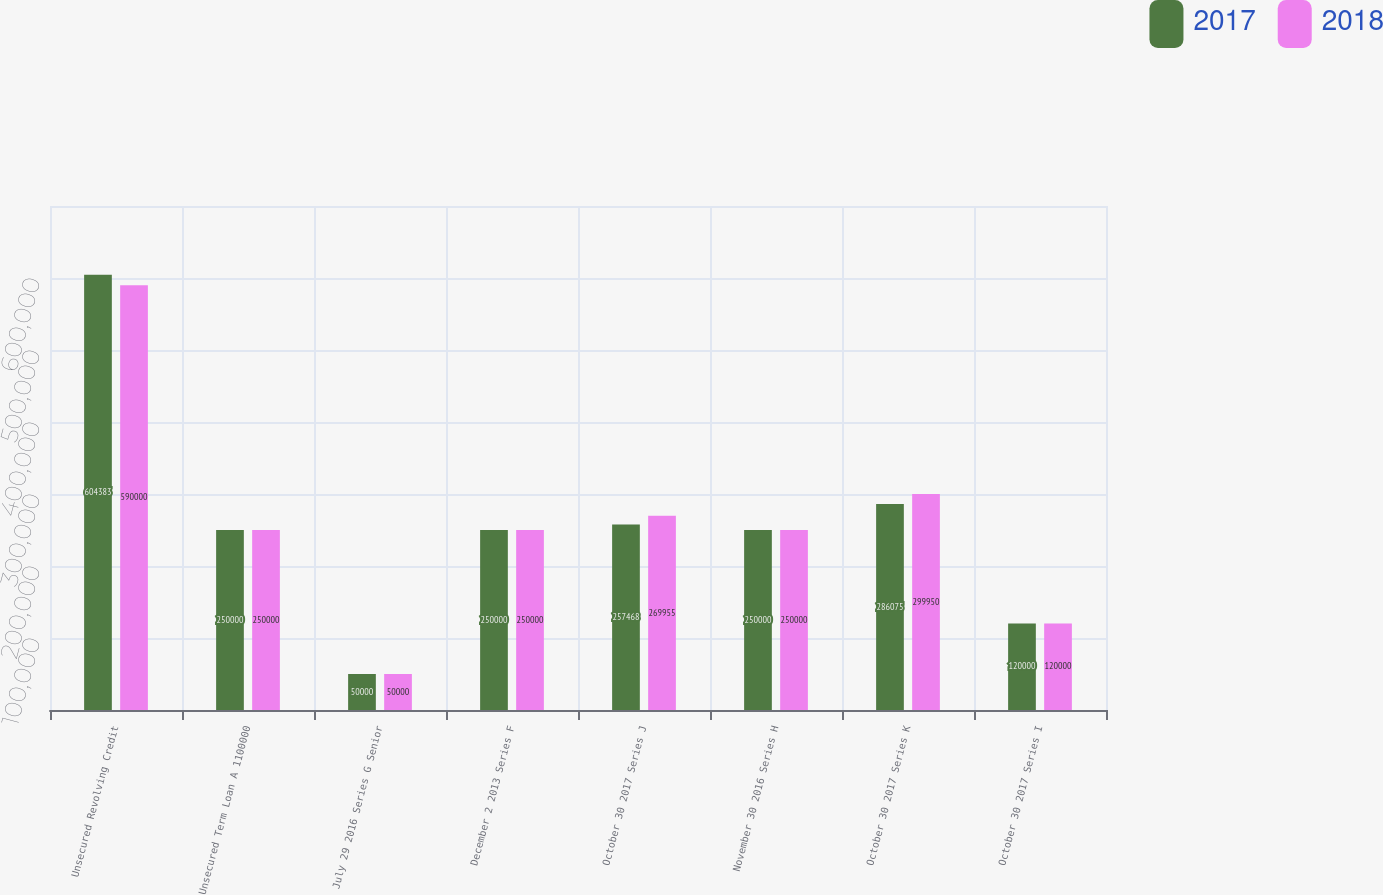Convert chart to OTSL. <chart><loc_0><loc_0><loc_500><loc_500><stacked_bar_chart><ecel><fcel>Unsecured Revolving Credit<fcel>Unsecured Term Loan A 1100000<fcel>July 29 2016 Series G Senior<fcel>December 2 2013 Series F<fcel>October 30 2017 Series J<fcel>November 30 2016 Series H<fcel>October 30 2017 Series K<fcel>October 30 2017 Series I<nl><fcel>2017<fcel>604383<fcel>250000<fcel>50000<fcel>250000<fcel>257468<fcel>250000<fcel>286075<fcel>120000<nl><fcel>2018<fcel>590000<fcel>250000<fcel>50000<fcel>250000<fcel>269955<fcel>250000<fcel>299950<fcel>120000<nl></chart> 